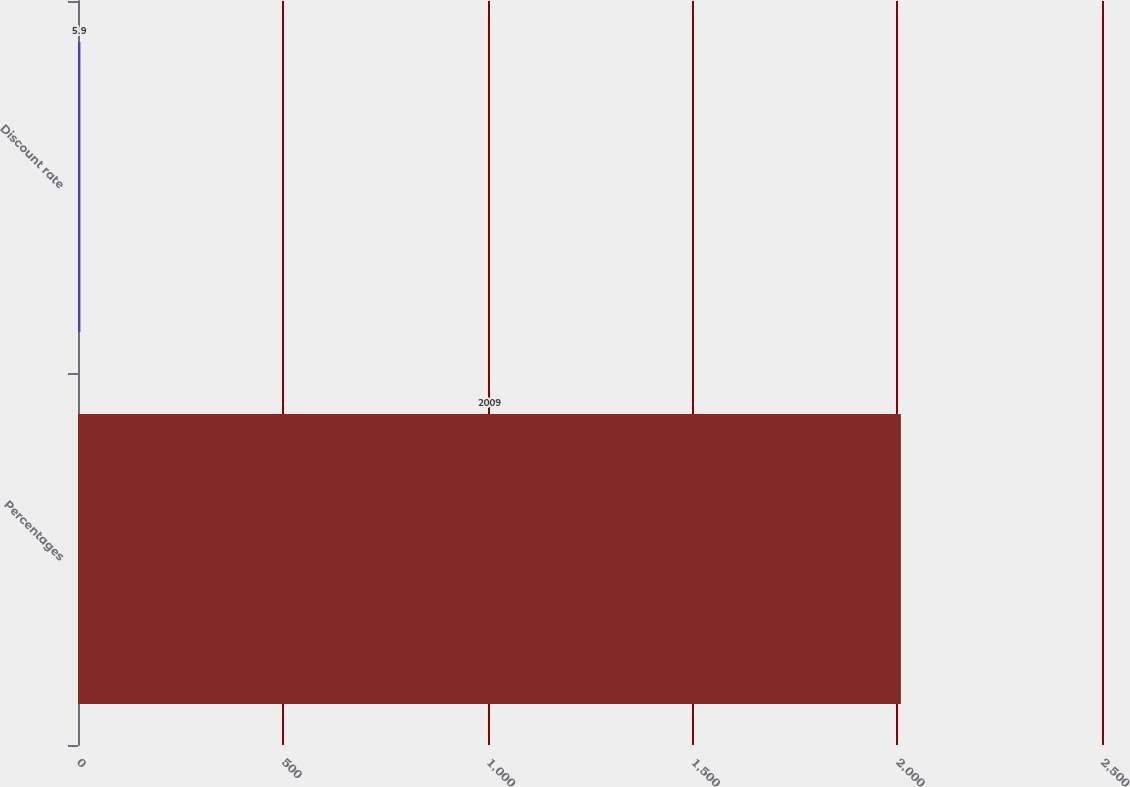Convert chart. <chart><loc_0><loc_0><loc_500><loc_500><bar_chart><fcel>Percentages<fcel>Discount rate<nl><fcel>2009<fcel>5.9<nl></chart> 